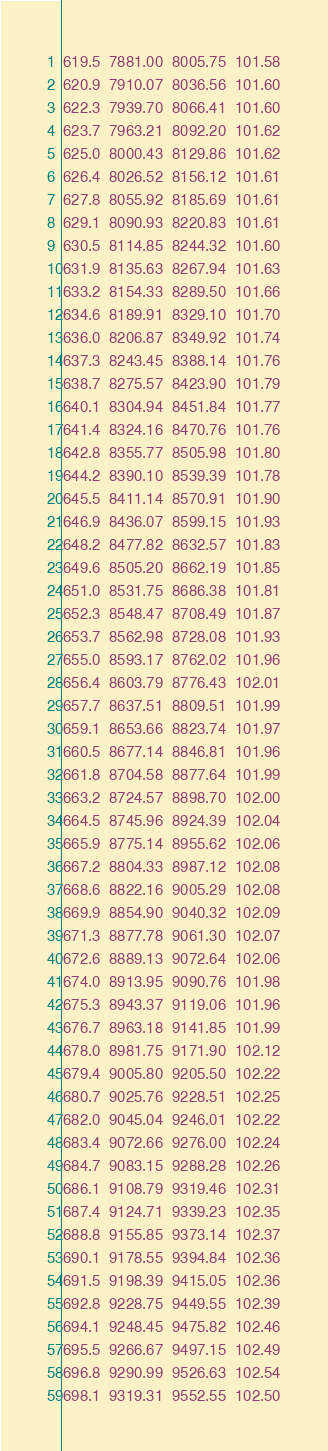Convert code to text. <code><loc_0><loc_0><loc_500><loc_500><_SML_>619.5  7881.00  8005.75  101.58
620.9  7910.07  8036.56  101.60
622.3  7939.70  8066.41  101.60
623.7  7963.21  8092.20  101.62
625.0  8000.43  8129.86  101.62
626.4  8026.52  8156.12  101.61
627.8  8055.92  8185.69  101.61
629.1  8090.93  8220.83  101.61
630.5  8114.85  8244.32  101.60
631.9  8135.63  8267.94  101.63
633.2  8154.33  8289.50  101.66
634.6  8189.91  8329.10  101.70
636.0  8206.87  8349.92  101.74
637.3  8243.45  8388.14  101.76
638.7  8275.57  8423.90  101.79
640.1  8304.94  8451.84  101.77
641.4  8324.16  8470.76  101.76
642.8  8355.77  8505.98  101.80
644.2  8390.10  8539.39  101.78
645.5  8411.14  8570.91  101.90
646.9  8436.07  8599.15  101.93
648.2  8477.82  8632.57  101.83
649.6  8505.20  8662.19  101.85
651.0  8531.75  8686.38  101.81
652.3  8548.47  8708.49  101.87
653.7  8562.98  8728.08  101.93
655.0  8593.17  8762.02  101.96
656.4  8603.79  8776.43  102.01
657.7  8637.51  8809.51  101.99
659.1  8653.66  8823.74  101.97
660.5  8677.14  8846.81  101.96
661.8  8704.58  8877.64  101.99
663.2  8724.57  8898.70  102.00
664.5  8745.96  8924.39  102.04
665.9  8775.14  8955.62  102.06
667.2  8804.33  8987.12  102.08
668.6  8822.16  9005.29  102.08
669.9  8854.90  9040.32  102.09
671.3  8877.78  9061.30  102.07
672.6  8889.13  9072.64  102.06
674.0  8913.95  9090.76  101.98
675.3  8943.37  9119.06  101.96
676.7  8963.18  9141.85  101.99
678.0  8981.75  9171.90  102.12
679.4  9005.80  9205.50  102.22
680.7  9025.76  9228.51  102.25
682.0  9045.04  9246.01  102.22
683.4  9072.66  9276.00  102.24
684.7  9083.15  9288.28  102.26
686.1  9108.79  9319.46  102.31
687.4  9124.71  9339.23  102.35
688.8  9155.85  9373.14  102.37
690.1  9178.55  9394.84  102.36
691.5  9198.39  9415.05  102.36
692.8  9228.75  9449.55  102.39
694.1  9248.45  9475.82  102.46
695.5  9266.67  9497.15  102.49
696.8  9290.99  9526.63  102.54
698.1  9319.31  9552.55  102.50</code> 